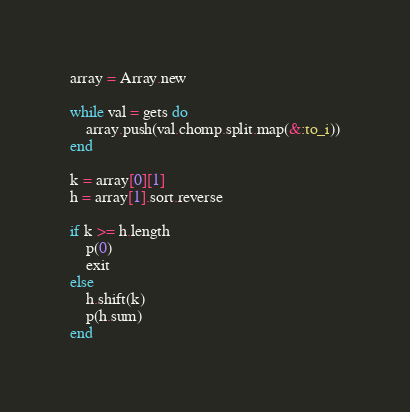<code> <loc_0><loc_0><loc_500><loc_500><_Ruby_>array = Array.new

while val = gets do
    array.push(val.chomp.split.map(&:to_i))
end

k = array[0][1]
h = array[1].sort.reverse

if k >= h.length
    p(0)
    exit
else
    h.shift(k)
    p(h.sum)
end</code> 